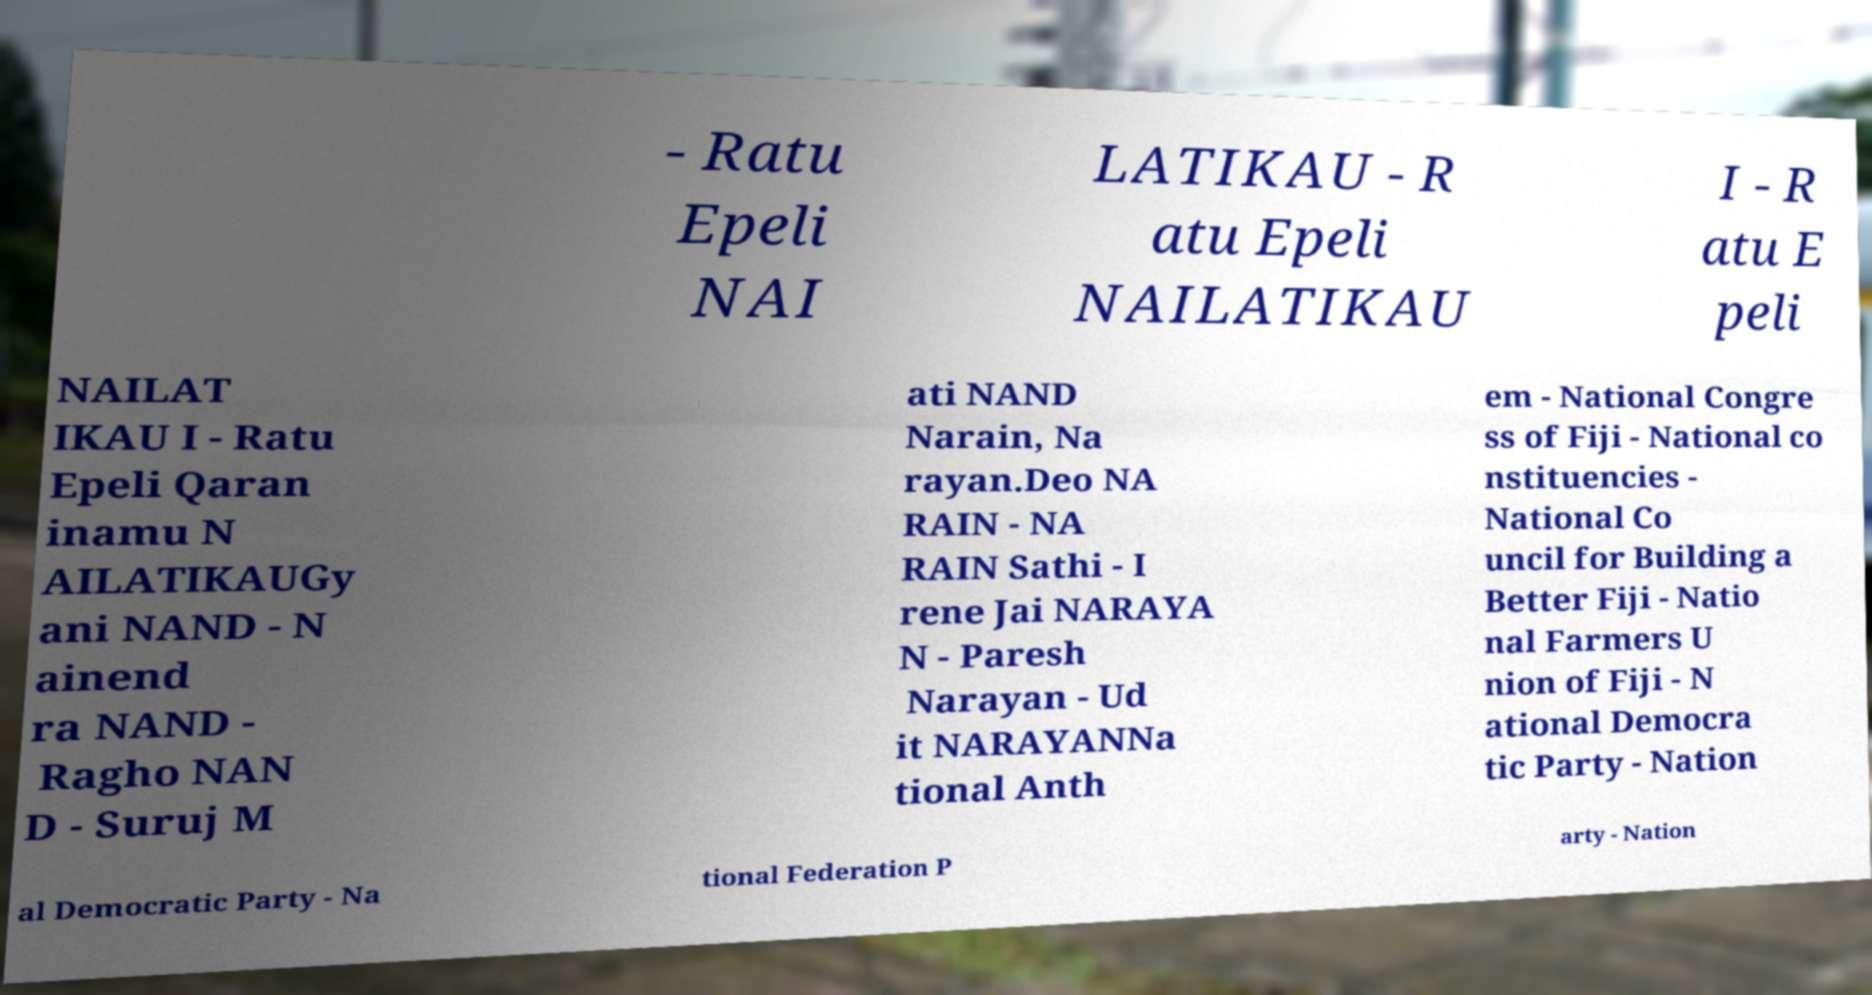Please read and relay the text visible in this image. What does it say? - Ratu Epeli NAI LATIKAU - R atu Epeli NAILATIKAU I - R atu E peli NAILAT IKAU I - Ratu Epeli Qaran inamu N AILATIKAUGy ani NAND - N ainend ra NAND - Ragho NAN D - Suruj M ati NAND Narain, Na rayan.Deo NA RAIN - NA RAIN Sathi - I rene Jai NARAYA N - Paresh Narayan - Ud it NARAYANNa tional Anth em - National Congre ss of Fiji - National co nstituencies - National Co uncil for Building a Better Fiji - Natio nal Farmers U nion of Fiji - N ational Democra tic Party - Nation al Democratic Party - Na tional Federation P arty - Nation 